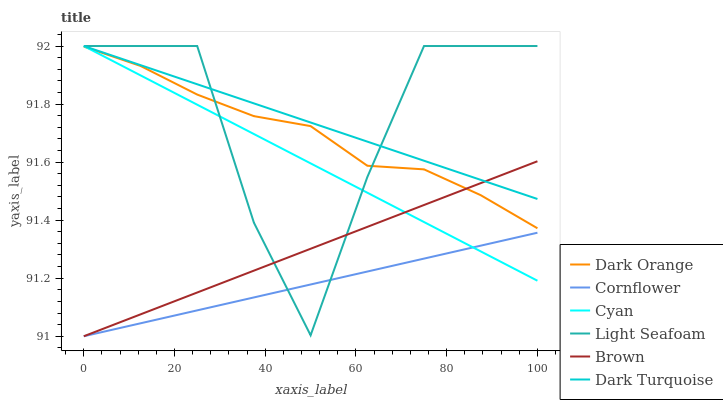Does Cornflower have the minimum area under the curve?
Answer yes or no. Yes. Does Light Seafoam have the maximum area under the curve?
Answer yes or no. Yes. Does Brown have the minimum area under the curve?
Answer yes or no. No. Does Brown have the maximum area under the curve?
Answer yes or no. No. Is Brown the smoothest?
Answer yes or no. Yes. Is Light Seafoam the roughest?
Answer yes or no. Yes. Is Dark Turquoise the smoothest?
Answer yes or no. No. Is Dark Turquoise the roughest?
Answer yes or no. No. Does Brown have the lowest value?
Answer yes or no. Yes. Does Dark Turquoise have the lowest value?
Answer yes or no. No. Does Light Seafoam have the highest value?
Answer yes or no. Yes. Does Brown have the highest value?
Answer yes or no. No. Is Cornflower less than Dark Orange?
Answer yes or no. Yes. Is Dark Orange greater than Cornflower?
Answer yes or no. Yes. Does Cyan intersect Brown?
Answer yes or no. Yes. Is Cyan less than Brown?
Answer yes or no. No. Is Cyan greater than Brown?
Answer yes or no. No. Does Cornflower intersect Dark Orange?
Answer yes or no. No. 